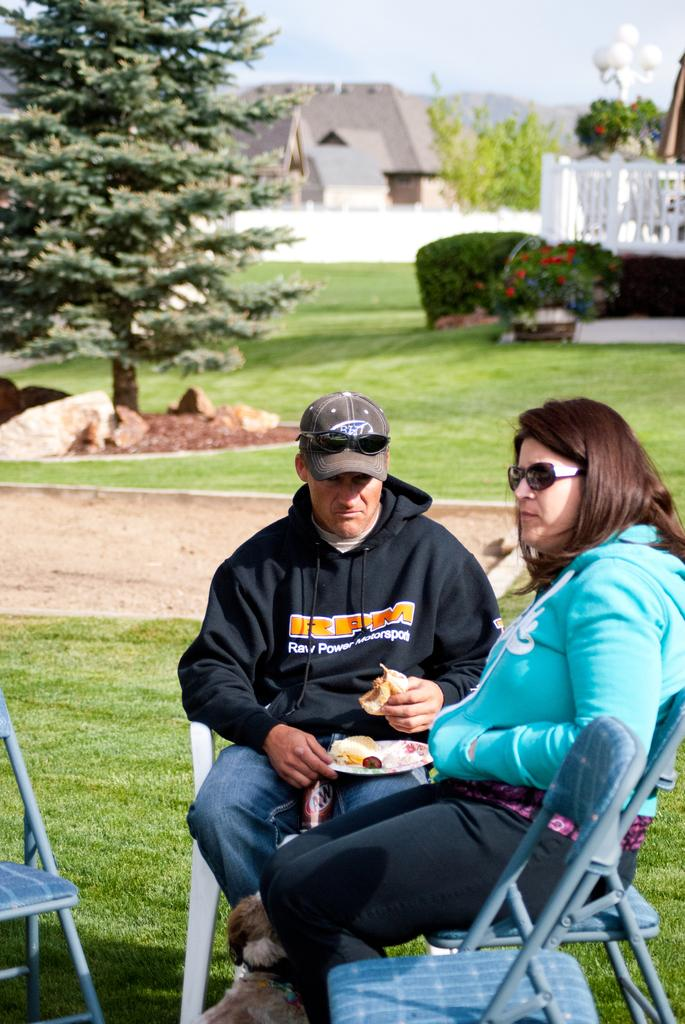How many people are in the image? There are two people in the image, a man and a woman. What are the man and woman doing in the image? Both the man and woman are sitting on chairs. What can be seen in the background of the image? There is green grass on the ground, green trees, and the sky is visible at the top of the image. What type of apparatus is being used by the man and woman in the image? There is no apparatus visible in the image; the man and woman are simply sitting on chairs. What causes the green trees to grow in the background of the image? The cause of the green trees growing in the background of the image is not visible or mentioned in the image. 